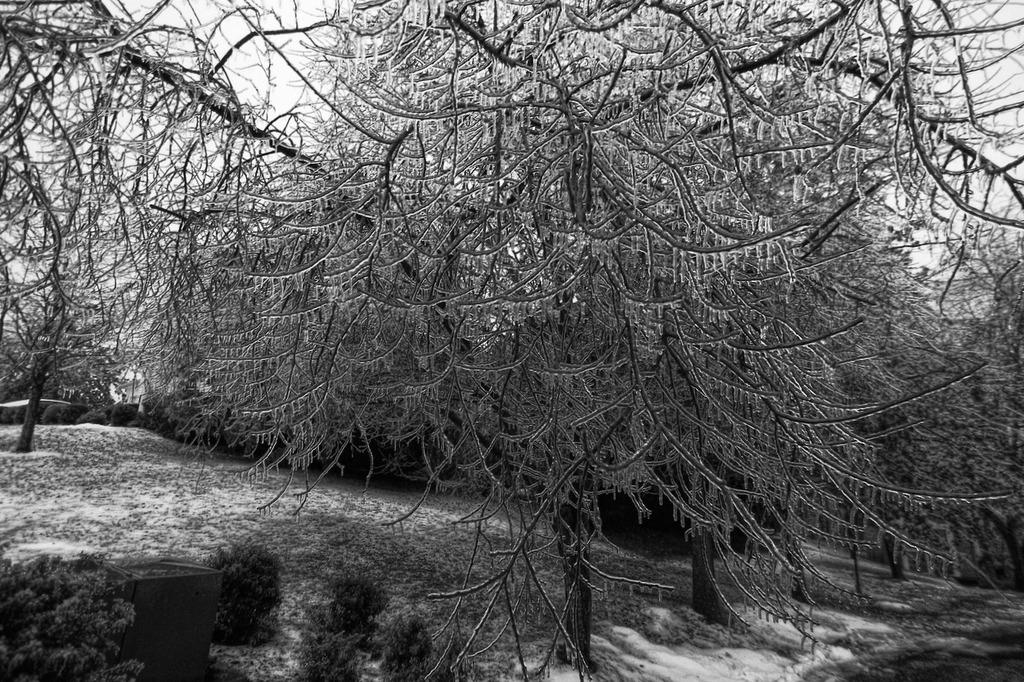What type of vegetation is present in the image? There are many trees in the image. What is the ground covered with at the bottom of the image? There is snow at the bottom of the image. Can you describe the setting of the image? The image appears to be taken in a forest. Are there any dinosaurs visible in the image? No, there are no dinosaurs present in the image. 